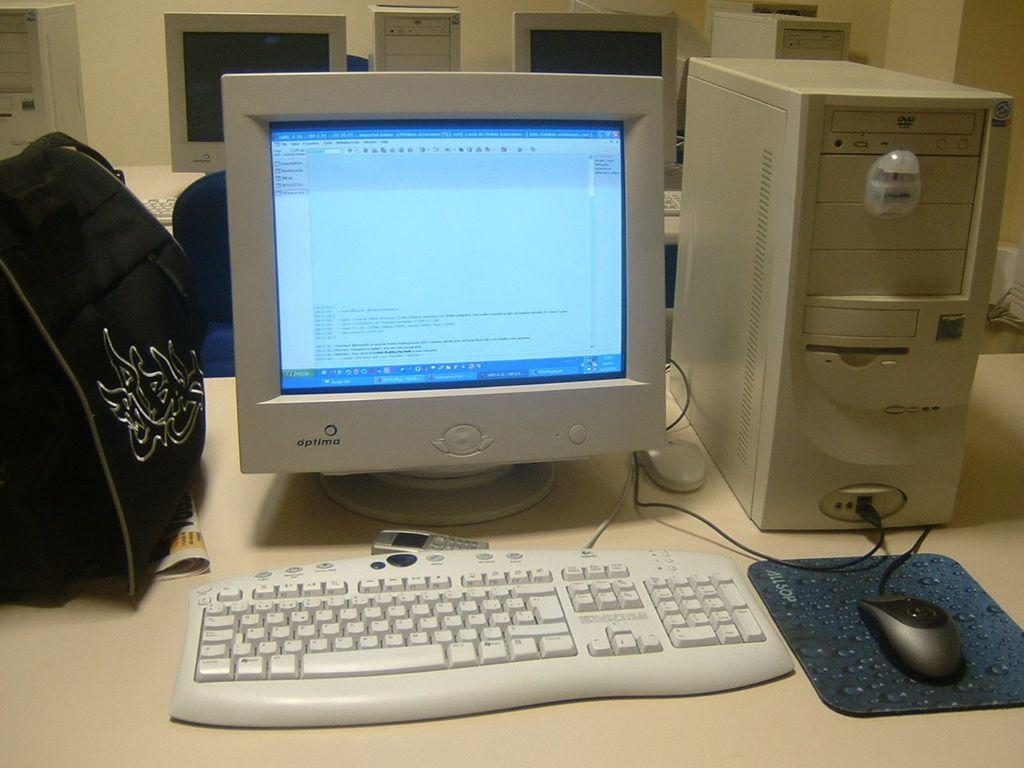What type of device is visible in the image? There is a monitor in the image. What other computer peripherals can be seen in the image? There is a keyboard and a mouse in the image. What is the main component of a computer system? There is a CPU in the image. What is present on the table in the image? There is a bag on the table in the image. What can be seen in the background of the image? There are systems visible in the background of the image. What color is the wall in the background of the image? The wall in the background is in cream color. What type of pies are being served in the image? There are no pies present in the image; it features computer devices and a bag on a table. 